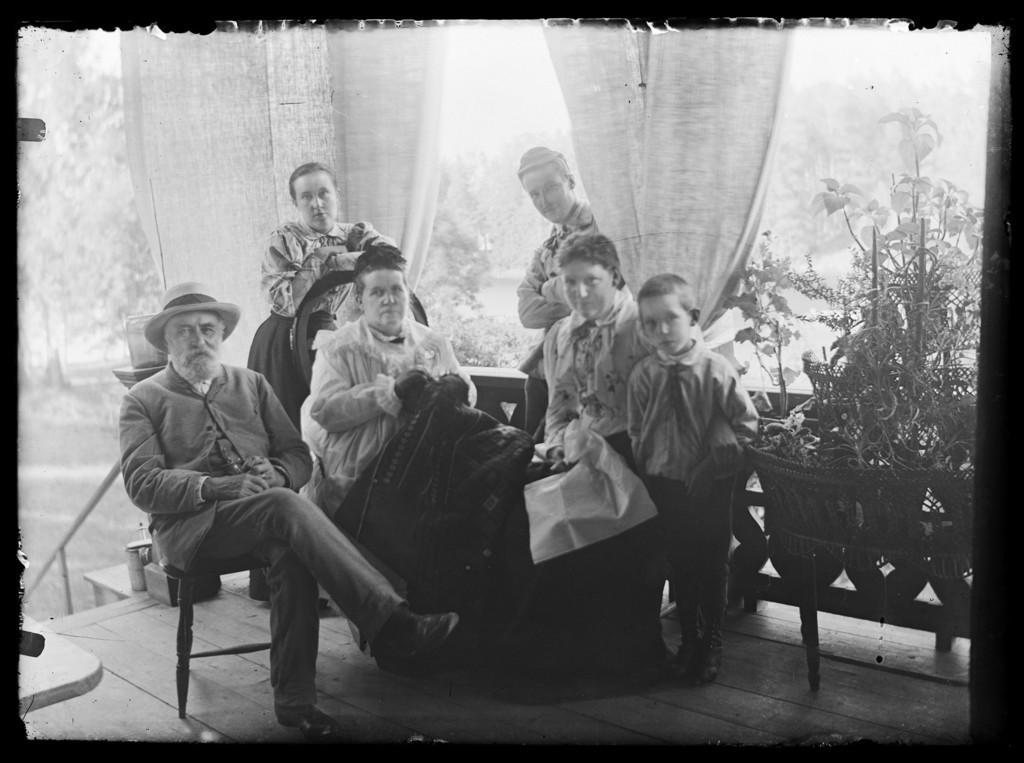Can you describe this image briefly? This is a black and white picture. In this picture, we see three people are standing and three people are sitting. They might be posing for the photo. Behind them, we see the railing and the curtains. On the right side, we see the plant pots. There are trees in the background. This might be a photo frame. 